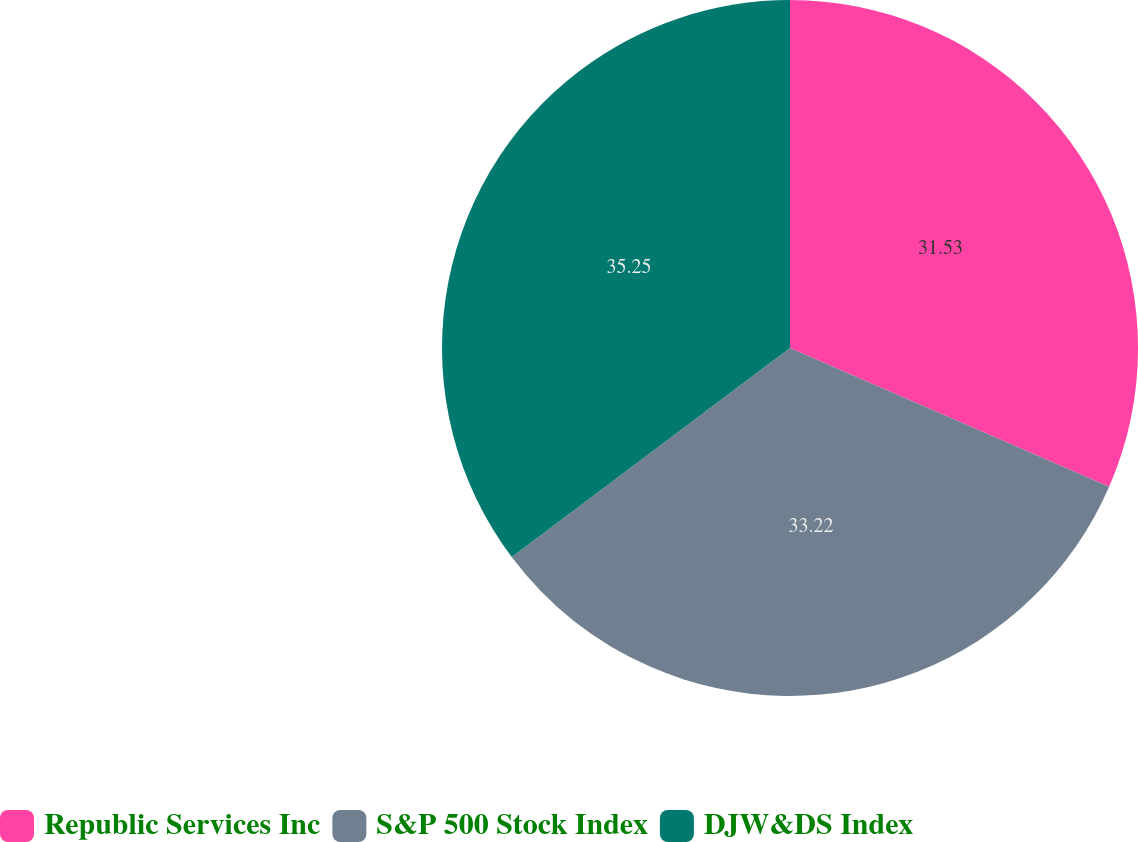Convert chart. <chart><loc_0><loc_0><loc_500><loc_500><pie_chart><fcel>Republic Services Inc<fcel>S&P 500 Stock Index<fcel>DJW&DS Index<nl><fcel>31.53%<fcel>33.22%<fcel>35.25%<nl></chart> 